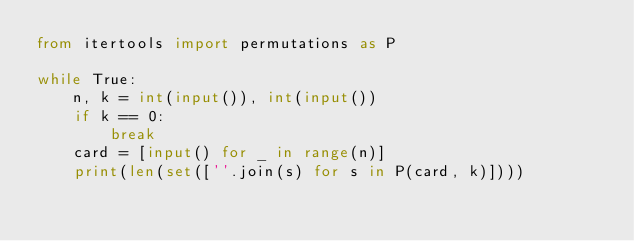Convert code to text. <code><loc_0><loc_0><loc_500><loc_500><_Python_>from itertools import permutations as P

while True:
    n, k = int(input()), int(input())
    if k == 0:
        break
    card = [input() for _ in range(n)]
    print(len(set([''.join(s) for s in P(card, k)])))</code> 